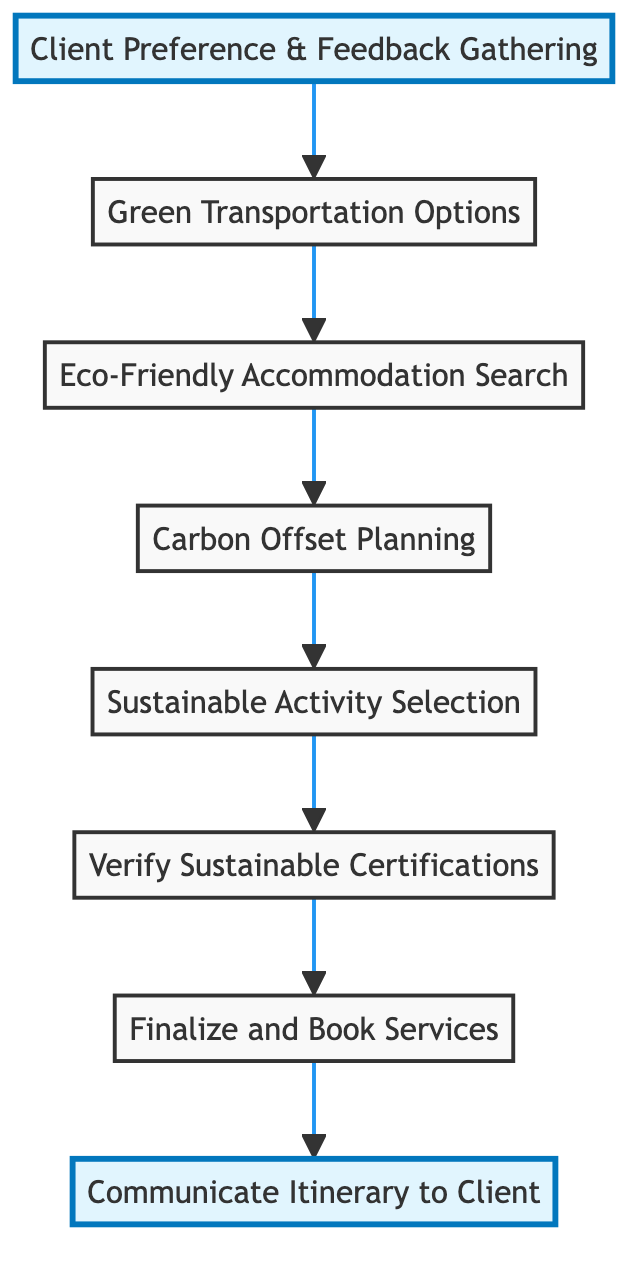What is the first step in the itinerary organization process? The diagram shows that the first step is "Client Preference & Feedback Gathering." This step initiates the process and leads to other actions.
Answer: Client Preference & Feedback Gathering How many total steps are in the diagram? By counting each node in the flowchart, we see that there are eight total steps from "Client Preference & Feedback Gathering" to "Communicate Itinerary to Client."
Answer: Eight What is the last step before communicating the itinerary? The flowchart indicates that the step before communicating the itinerary is "Finalize and Book Services." This is the penultimate action that occurs prior to the final communication.
Answer: Finalize and Book Services Which step involves selecting sustainable activities? The diagram shows that "Sustainable Activity Selection" is dedicated to this task. It follows "Carbon Offset Planning" and precedes the verification of sustainable certifications.
Answer: Sustainable Activity Selection What sustainable practices are checked for in "Verify Sustainable Certifications"? This step involves checking for credible sustainability certifications like Green Globe, EarthCheck, or LEED. It ensures that chosen accommodations and service providers are genuinely sustainable.
Answer: Credible sustainability certifications What type of transportation options are favored? The diagram specifies that "Green Transportation Options" favors low-emission transportation alternatives. This includes electric or hybrid vehicles, public transport, biking, and walking.
Answer: Low-emission transportation options Which two steps immediately follow "Eco-Friendly Accommodation Search"? After "Eco-Friendly Accommodation Search," the subsequent steps are "Carbon Offset Planning" and then "Sustainable Activity Selection." This shows the sequential actions that follow the accommodation search.
Answer: Carbon Offset Planning and Sustainable Activity Selection How are carbon emissions addressed in the itinerary? The itinerary addresses carbon emissions in the "Carbon Offset Planning" step, where options for offsetting emissions are discussed, such as investments in reforestation projects.
Answer: Carbon Offset Planning 